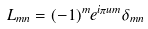Convert formula to latex. <formula><loc_0><loc_0><loc_500><loc_500>L _ { m n } = ( - 1 ) ^ { m } e ^ { i \pi u m } \delta _ { m n }</formula> 